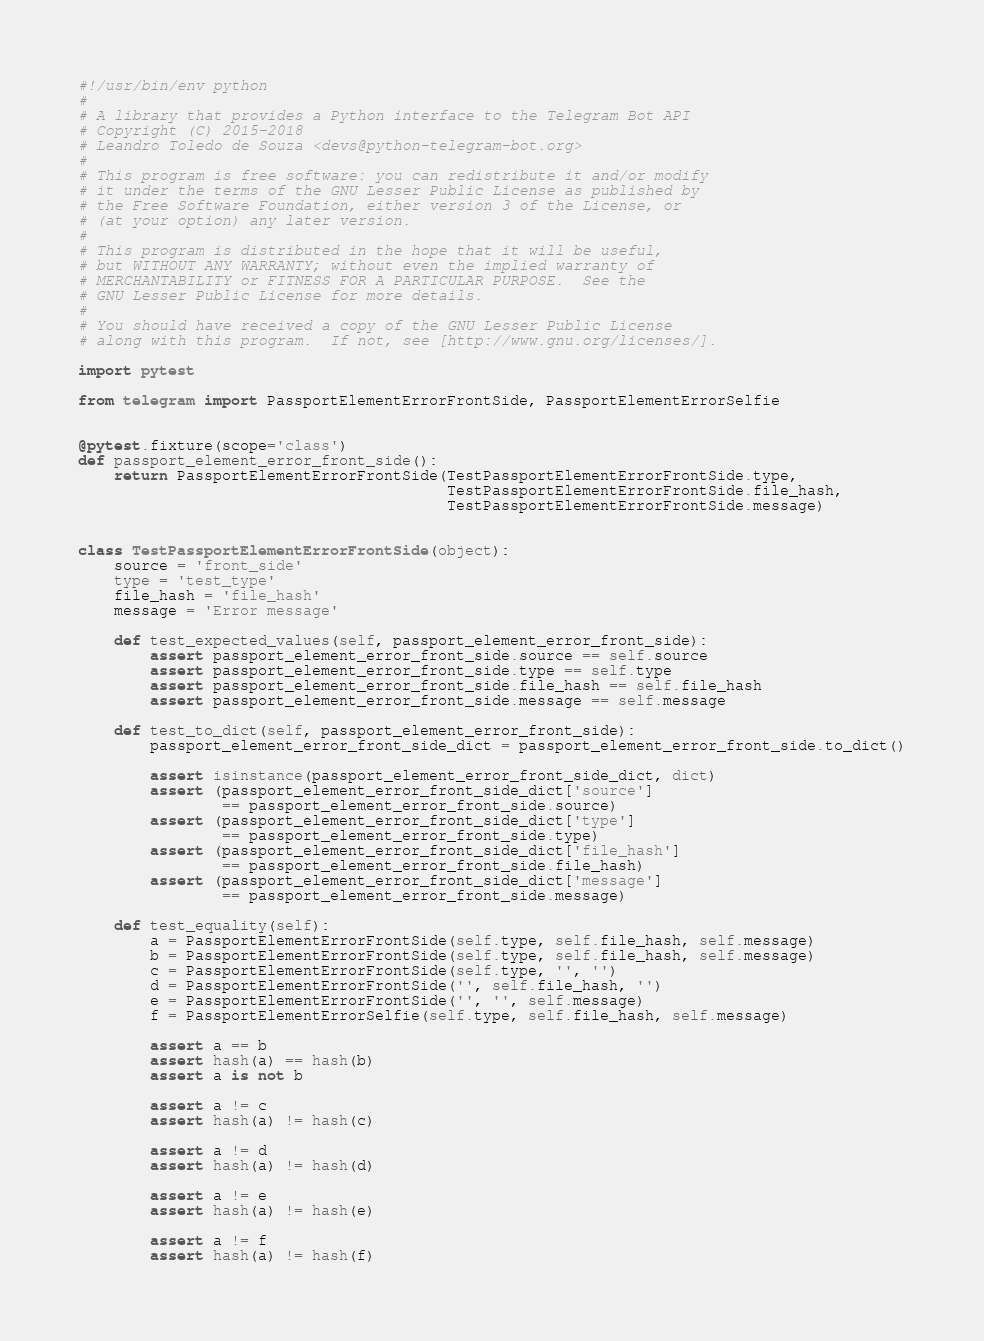Convert code to text. <code><loc_0><loc_0><loc_500><loc_500><_Python_>#!/usr/bin/env python
#
# A library that provides a Python interface to the Telegram Bot API
# Copyright (C) 2015-2018
# Leandro Toledo de Souza <devs@python-telegram-bot.org>
#
# This program is free software: you can redistribute it and/or modify
# it under the terms of the GNU Lesser Public License as published by
# the Free Software Foundation, either version 3 of the License, or
# (at your option) any later version.
#
# This program is distributed in the hope that it will be useful,
# but WITHOUT ANY WARRANTY; without even the implied warranty of
# MERCHANTABILITY or FITNESS FOR A PARTICULAR PURPOSE.  See the
# GNU Lesser Public License for more details.
#
# You should have received a copy of the GNU Lesser Public License
# along with this program.  If not, see [http://www.gnu.org/licenses/].

import pytest

from telegram import PassportElementErrorFrontSide, PassportElementErrorSelfie


@pytest.fixture(scope='class')
def passport_element_error_front_side():
    return PassportElementErrorFrontSide(TestPassportElementErrorFrontSide.type,
                                         TestPassportElementErrorFrontSide.file_hash,
                                         TestPassportElementErrorFrontSide.message)


class TestPassportElementErrorFrontSide(object):
    source = 'front_side'
    type = 'test_type'
    file_hash = 'file_hash'
    message = 'Error message'

    def test_expected_values(self, passport_element_error_front_side):
        assert passport_element_error_front_side.source == self.source
        assert passport_element_error_front_side.type == self.type
        assert passport_element_error_front_side.file_hash == self.file_hash
        assert passport_element_error_front_side.message == self.message

    def test_to_dict(self, passport_element_error_front_side):
        passport_element_error_front_side_dict = passport_element_error_front_side.to_dict()

        assert isinstance(passport_element_error_front_side_dict, dict)
        assert (passport_element_error_front_side_dict['source']
                == passport_element_error_front_side.source)
        assert (passport_element_error_front_side_dict['type']
                == passport_element_error_front_side.type)
        assert (passport_element_error_front_side_dict['file_hash']
                == passport_element_error_front_side.file_hash)
        assert (passport_element_error_front_side_dict['message']
                == passport_element_error_front_side.message)

    def test_equality(self):
        a = PassportElementErrorFrontSide(self.type, self.file_hash, self.message)
        b = PassportElementErrorFrontSide(self.type, self.file_hash, self.message)
        c = PassportElementErrorFrontSide(self.type, '', '')
        d = PassportElementErrorFrontSide('', self.file_hash, '')
        e = PassportElementErrorFrontSide('', '', self.message)
        f = PassportElementErrorSelfie(self.type, self.file_hash, self.message)

        assert a == b
        assert hash(a) == hash(b)
        assert a is not b

        assert a != c
        assert hash(a) != hash(c)

        assert a != d
        assert hash(a) != hash(d)

        assert a != e
        assert hash(a) != hash(e)

        assert a != f
        assert hash(a) != hash(f)
</code> 